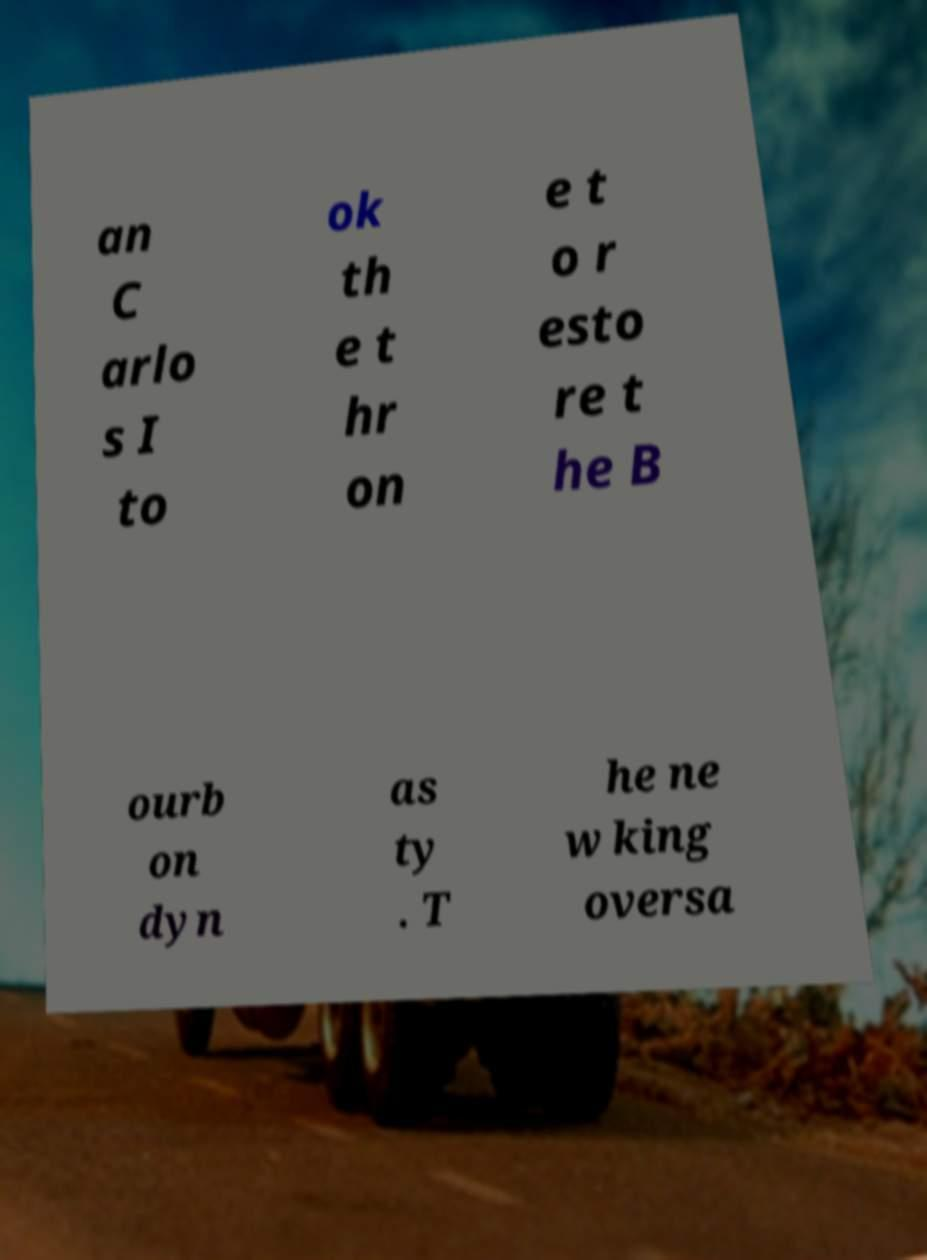Can you accurately transcribe the text from the provided image for me? an C arlo s I to ok th e t hr on e t o r esto re t he B ourb on dyn as ty . T he ne w king oversa 